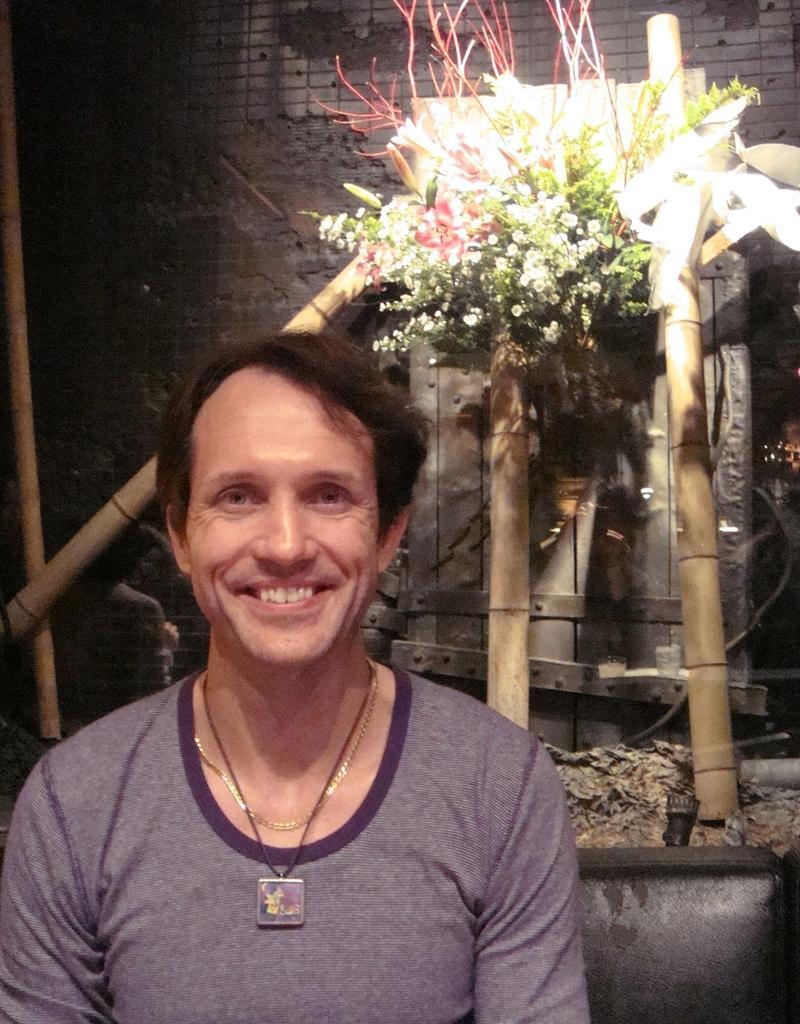Describe this image in one or two sentences. This is a zoomed in picture. In the foreground there is a person wearing t-shirt and smiling. In the background we can see the bamboo, flowers, wall and some other items. 